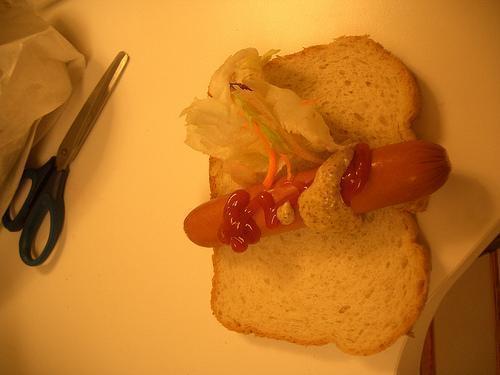How many slices of bread are there?
Give a very brief answer. 1. 